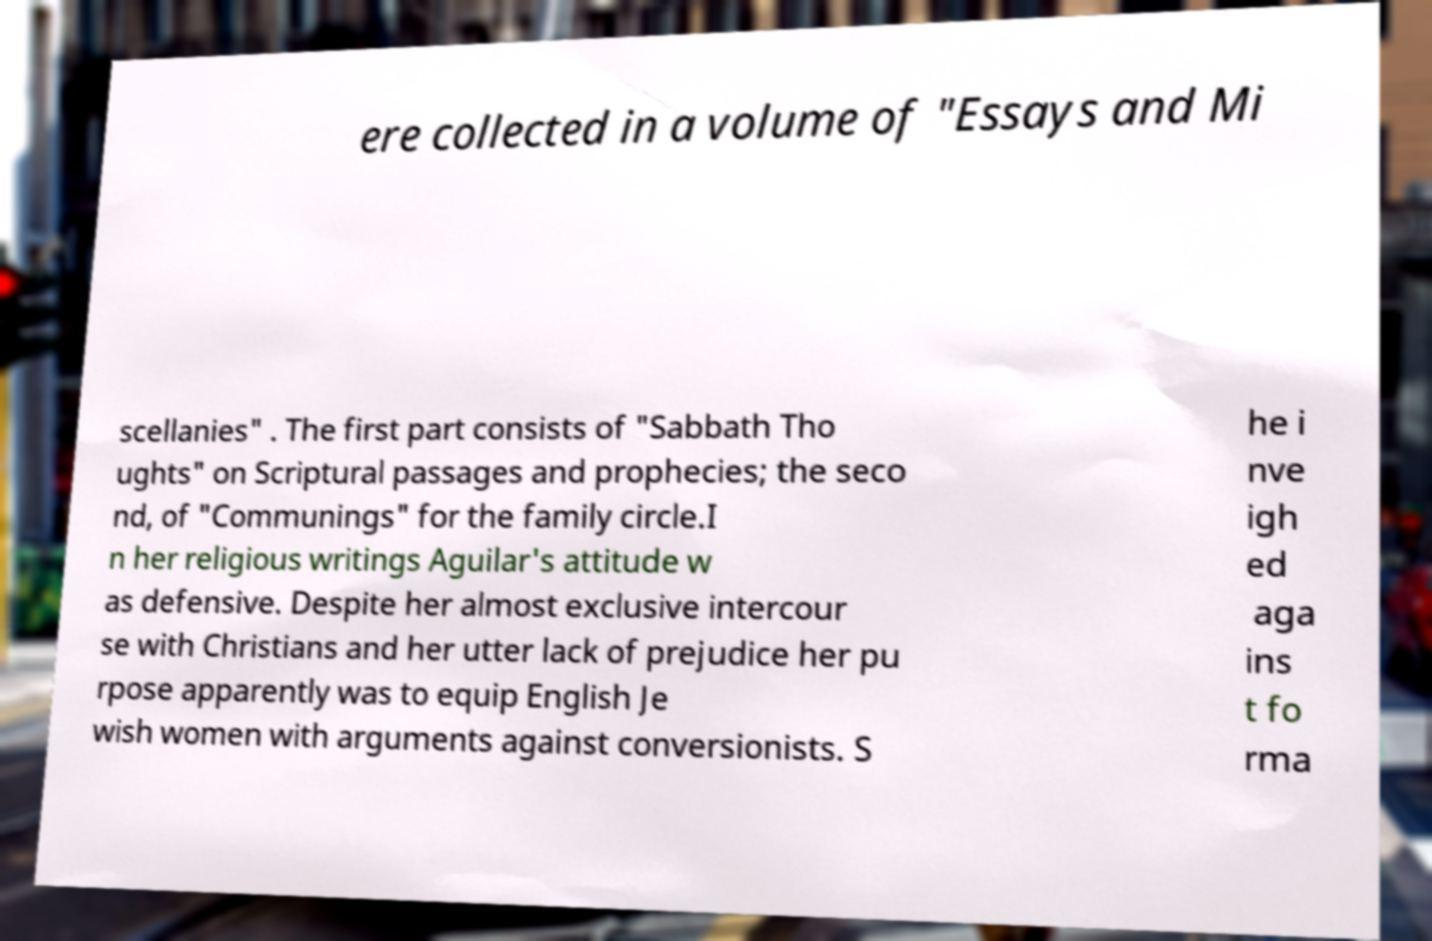I need the written content from this picture converted into text. Can you do that? ere collected in a volume of "Essays and Mi scellanies" . The first part consists of "Sabbath Tho ughts" on Scriptural passages and prophecies; the seco nd, of "Communings" for the family circle.I n her religious writings Aguilar's attitude w as defensive. Despite her almost exclusive intercour se with Christians and her utter lack of prejudice her pu rpose apparently was to equip English Je wish women with arguments against conversionists. S he i nve igh ed aga ins t fo rma 